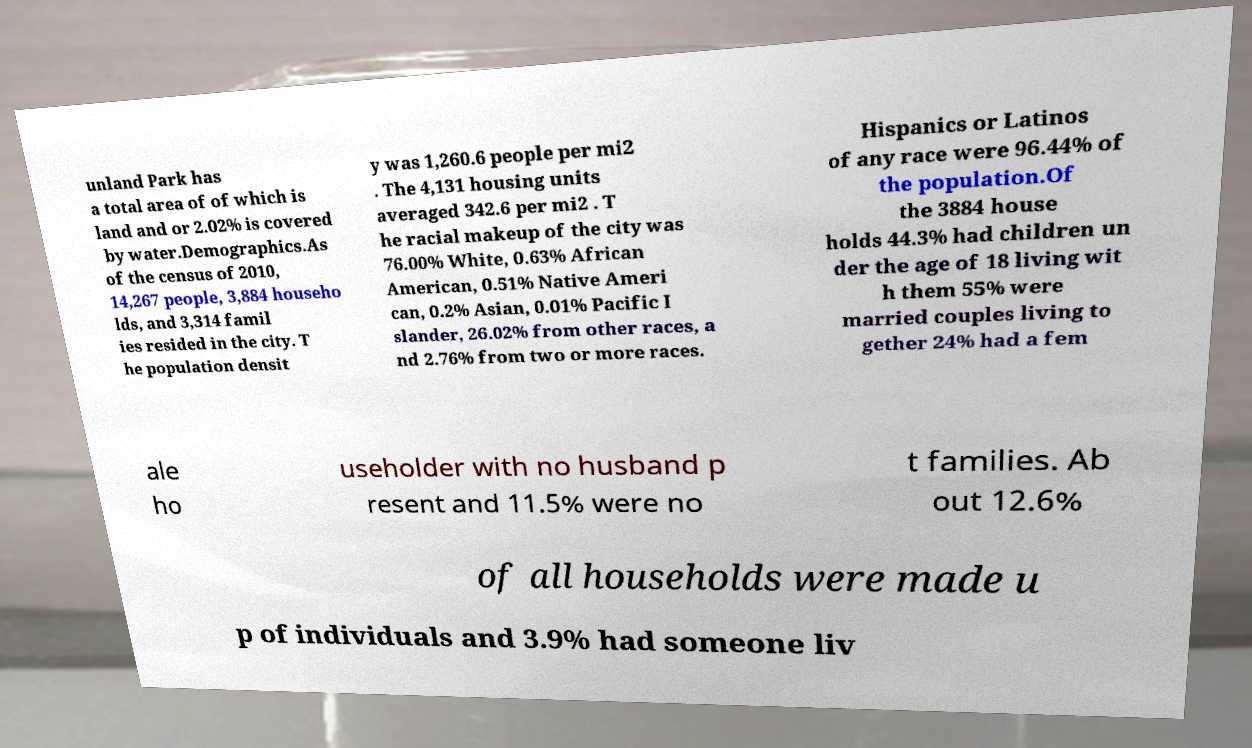Can you read and provide the text displayed in the image?This photo seems to have some interesting text. Can you extract and type it out for me? unland Park has a total area of of which is land and or 2.02% is covered by water.Demographics.As of the census of 2010, 14,267 people, 3,884 househo lds, and 3,314 famil ies resided in the city. T he population densit y was 1,260.6 people per mi2 . The 4,131 housing units averaged 342.6 per mi2 . T he racial makeup of the city was 76.00% White, 0.63% African American, 0.51% Native Ameri can, 0.2% Asian, 0.01% Pacific I slander, 26.02% from other races, a nd 2.76% from two or more races. Hispanics or Latinos of any race were 96.44% of the population.Of the 3884 house holds 44.3% had children un der the age of 18 living wit h them 55% were married couples living to gether 24% had a fem ale ho useholder with no husband p resent and 11.5% were no t families. Ab out 12.6% of all households were made u p of individuals and 3.9% had someone liv 